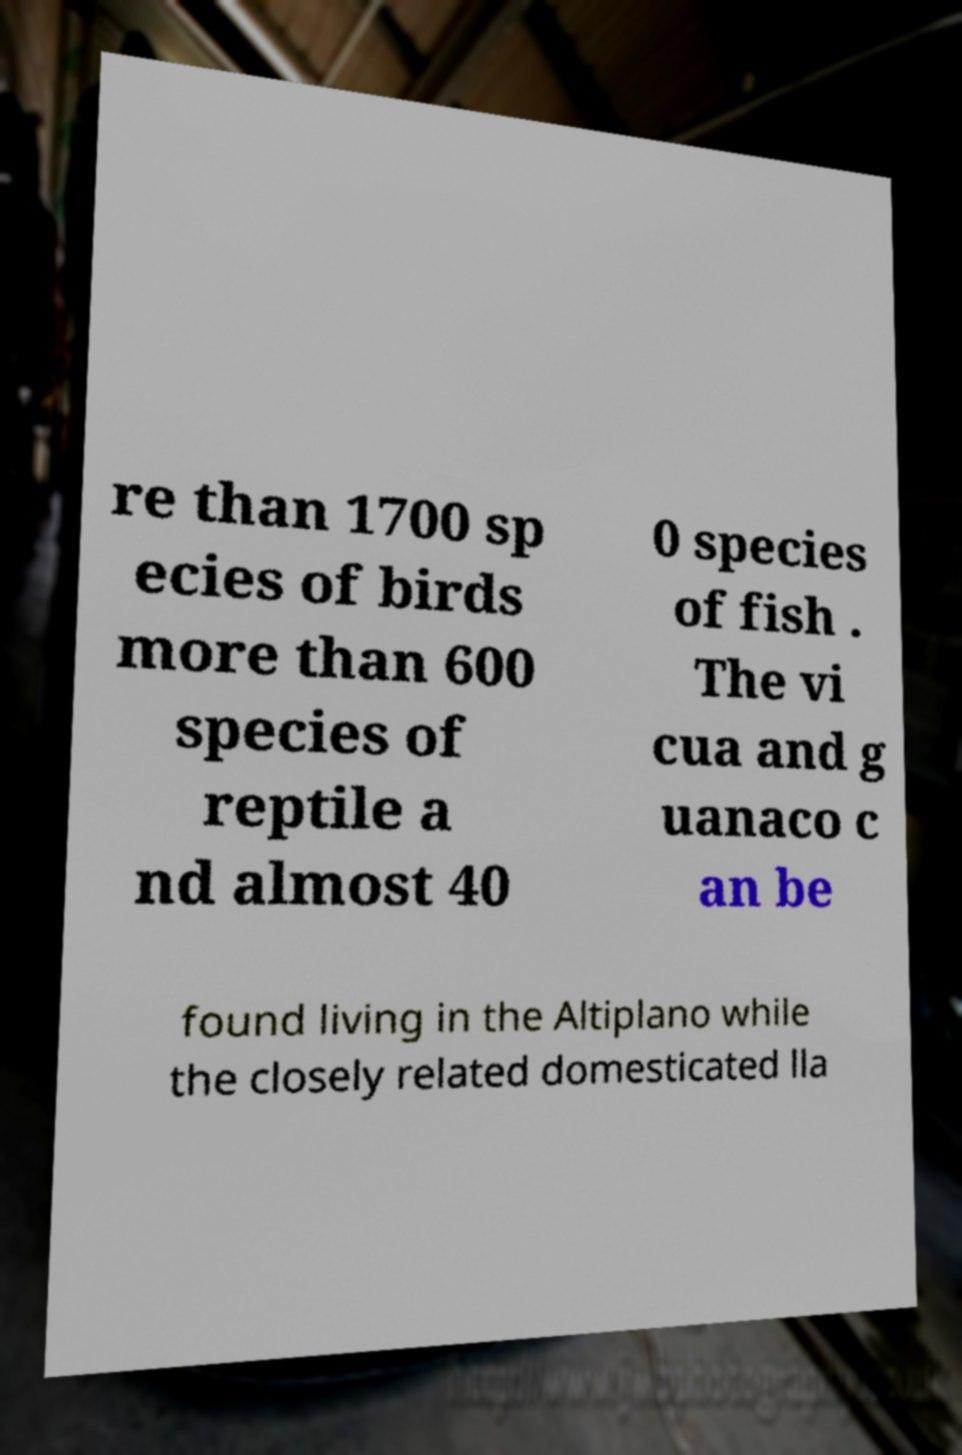I need the written content from this picture converted into text. Can you do that? re than 1700 sp ecies of birds more than 600 species of reptile a nd almost 40 0 species of fish . The vi cua and g uanaco c an be found living in the Altiplano while the closely related domesticated lla 